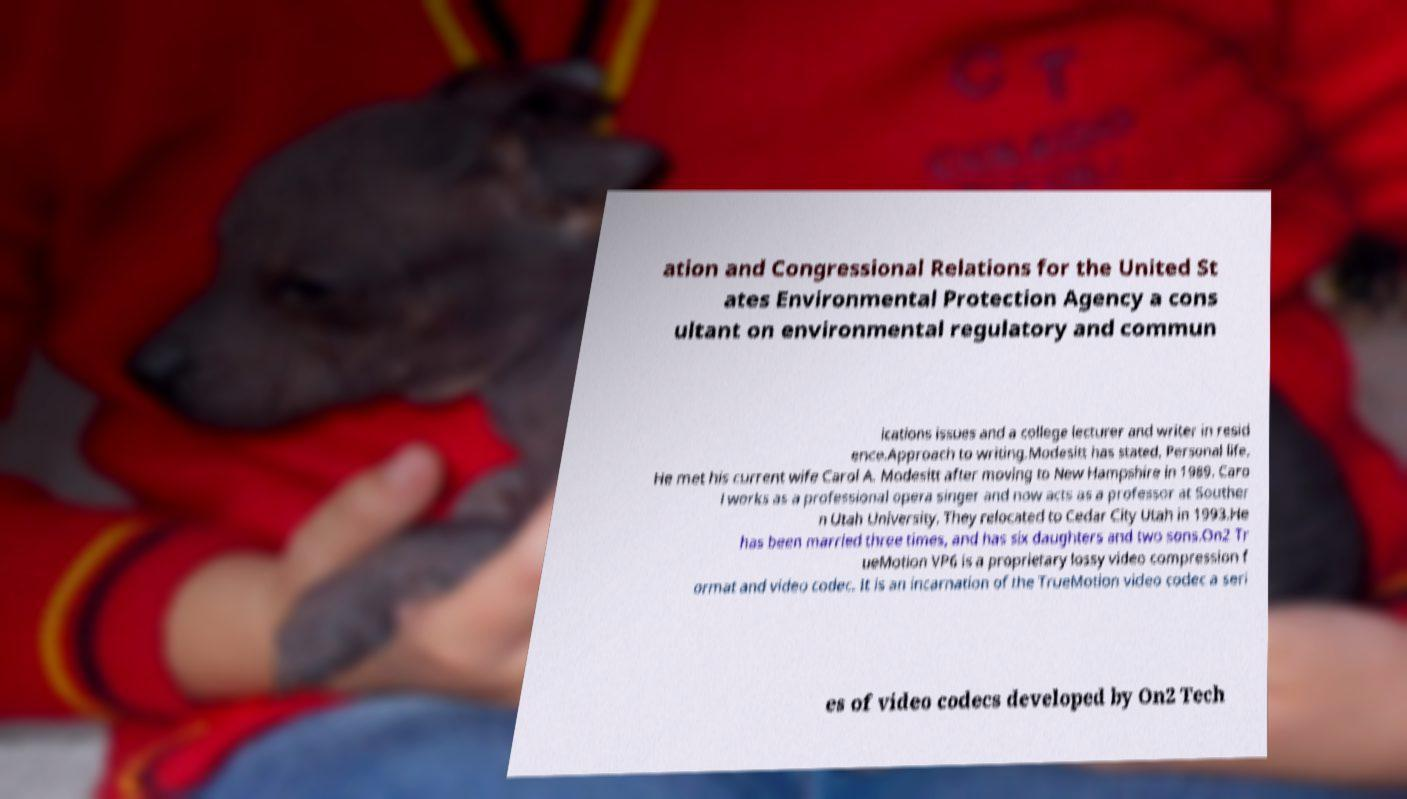For documentation purposes, I need the text within this image transcribed. Could you provide that? ation and Congressional Relations for the United St ates Environmental Protection Agency a cons ultant on environmental regulatory and commun ications issues and a college lecturer and writer in resid ence.Approach to writing.Modesitt has stated, Personal life. He met his current wife Carol A. Modesitt after moving to New Hampshire in 1989. Caro l works as a professional opera singer and now acts as a professor at Souther n Utah University. They relocated to Cedar City Utah in 1993.He has been married three times, and has six daughters and two sons.On2 Tr ueMotion VP6 is a proprietary lossy video compression f ormat and video codec. It is an incarnation of the TrueMotion video codec a seri es of video codecs developed by On2 Tech 